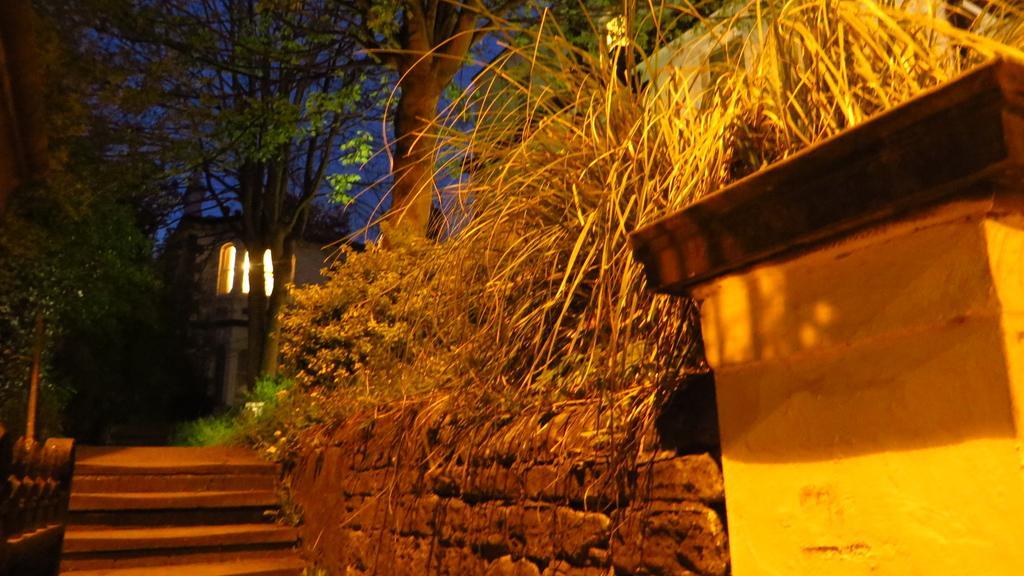Describe this image in one or two sentences. In this image there is a wall to that wall there are steps on either side of the steps there are trees, in the background there is a house. 